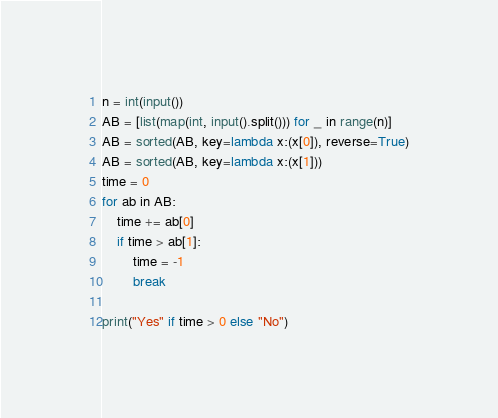<code> <loc_0><loc_0><loc_500><loc_500><_Python_>n = int(input())
AB = [list(map(int, input().split())) for _ in range(n)]
AB = sorted(AB, key=lambda x:(x[0]), reverse=True)
AB = sorted(AB, key=lambda x:(x[1]))
time = 0
for ab in AB:
    time += ab[0]
    if time > ab[1]:
        time = -1
        break

print("Yes" if time > 0 else "No")</code> 